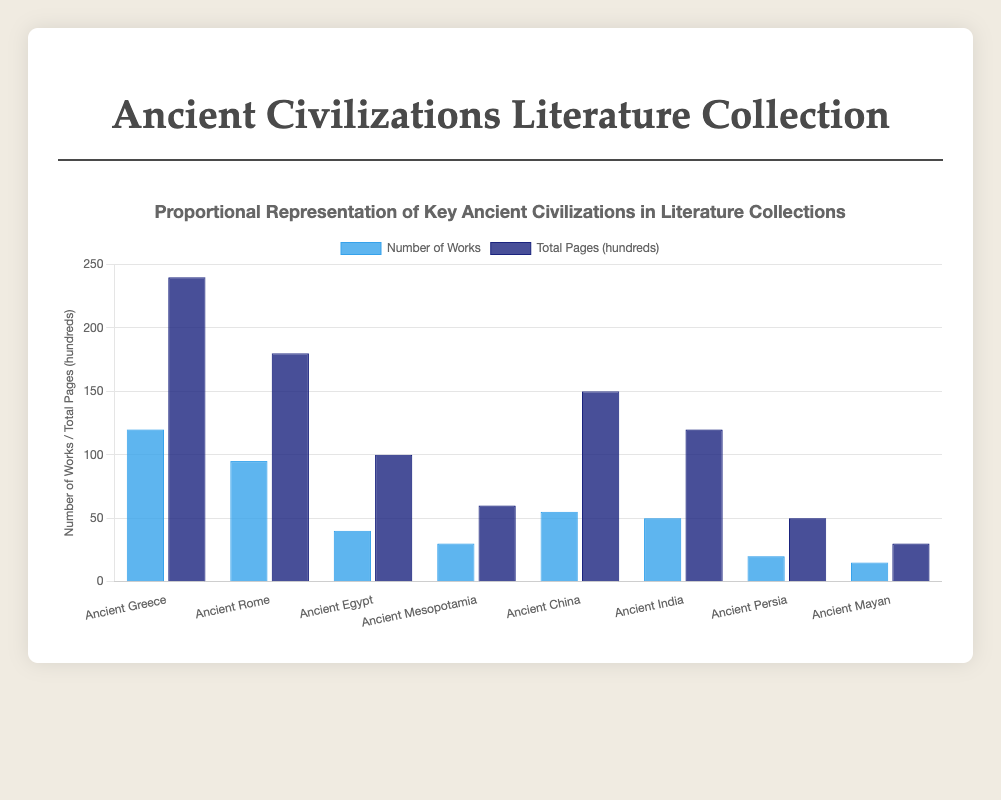What is the total number of works represented from Ancient Greece and Ancient Rome? For Ancient Greece, the number of works is 120 and for Ancient Rome, it is 95. Summing these gives 120 + 95 = 215.
Answer: 215 Which civilization has the highest number of total pages, and how many pages are there? The chart shows that Ancient Greece has the highest bar in the "Total Pages" category (converted to hundreds), which is 24000 pages.
Answer: Ancient Greece, 24000 pages Which civilization has the least number of works? The smallest bar in the "Number of Works" category is for the Ancient Mayan civilization, with 15 works.
Answer: Ancient Mayan How does the total number of pages of Ancient India compare with Ancient Egypt? To find this, we look at the bars for both civilizations in the "Total Pages" category. Ancient India has 12000 pages and Ancient Egypt has 10000 pages.
Answer: Ancient India has 2000 more pages than Ancient Egypt What is the average number of works across all the represented civilizations? Sum the number of works for all civilizations: 120 (Greece) + 95 (Rome) + 40 (Egypt) + 30 (Mesopotamia) + 55 (China) + 50 (India) + 20 (Persia) + 15 (Mayan) = 425. Then, divide by the number of civilizations (8): 425 / 8 = 53.125.
Answer: 53.125 Which civilization has the highest ratio of total pages to the number of works? Calculate the ratio for each civilization: Greece 24000/120 = 200; Rome 18000/95 = 189.47; Egypt 10000/40 = 250; Mesopotamia 6000/30 = 200; China 15000/55 = 272.73; India 12000/50 = 240; Persia 5000/20 = 250; Mayan 3000/15 = 200. The highest ratio is for Ancient China (272.73).
Answer: Ancient China Among Ancient Greece, Ancient Rome, and Ancient India, which has the lowest total pages, and by how much compared to the highest? Ancient Greece has 24000 pages, Ancient Rome has 18000 pages, and Ancient India has 12000 pages. The lowest among them is Ancient India with 12000 pages. The difference with the highest which is Ancient Greece is 24000 - 12000 = 12000.
Answer: Ancient India, 12000 pages What is the sum of total pages from Ancient Mesopotamia and Ancient Persia? Ancient Mesopotamia has 6000 pages and Ancient Persia has 5000 pages. The sum is 6000 + 5000 = 11000.
Answer: 11000 If each page represents on average 10 words, how many words are represented in Ancient China's total works? Ancient China has 15000 pages. If each page represents 10 words, the total words are 15000 * 10 = 150000.
Answer: 150000 By how much does the number of works from Ancient Egypt exceed that from Ancient Mesopotamia? Ancient Egypt has 40 works, while Ancient Mesopotamia has 30 works. The difference is 40 - 30 = 10.
Answer: 10 